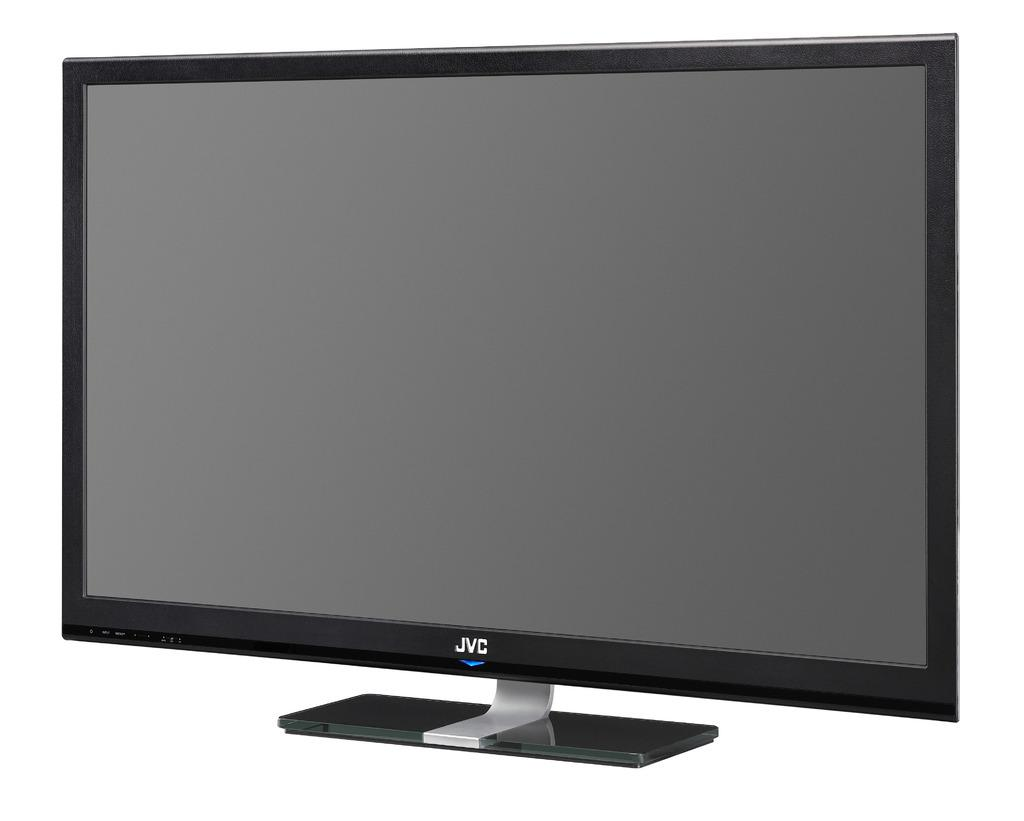<image>
Create a compact narrative representing the image presented. Black monitor that has the letters JVC on the bottom. 